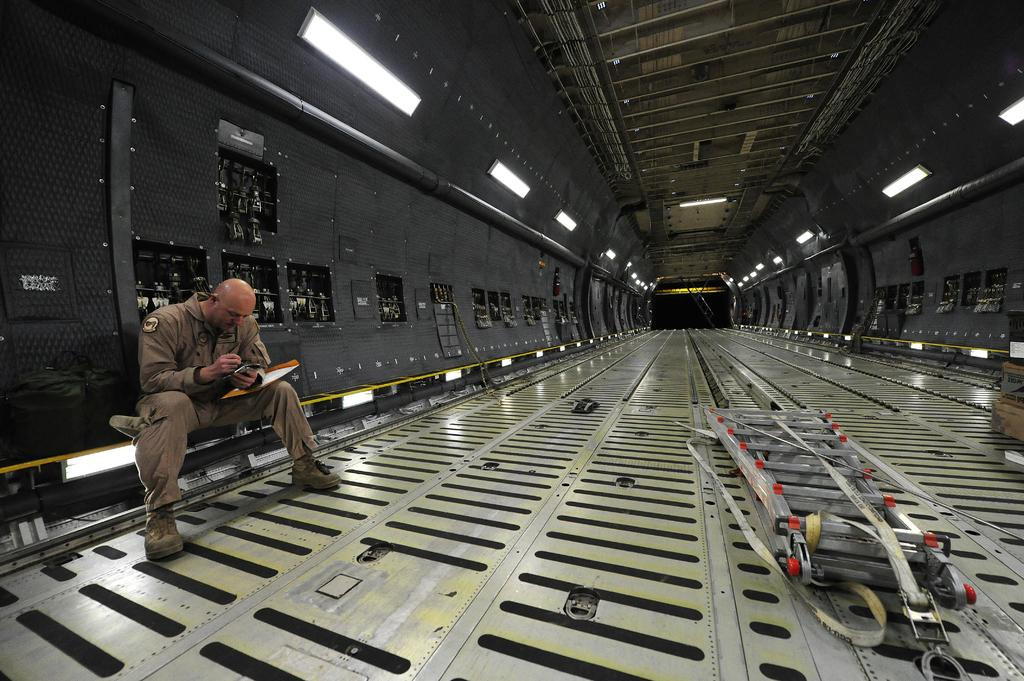What is the man in the image doing? The man is seated and holding a file and a mobile in his hand. What might the man be working on or looking at in the image? The man is holding a file, which suggests he might be working on or reviewing some documents. Can you describe the setting of the image? The image appears to be an inner view of a cargo plane, as indicated by the presence of a ladder and the overall appearance of the space. What can be seen in terms of lighting in the image? There are lights visible in the image. What type of brush is the man using to apply powder in the image? There is no brush or powder present in the image; the man is holding a file and a mobile. 